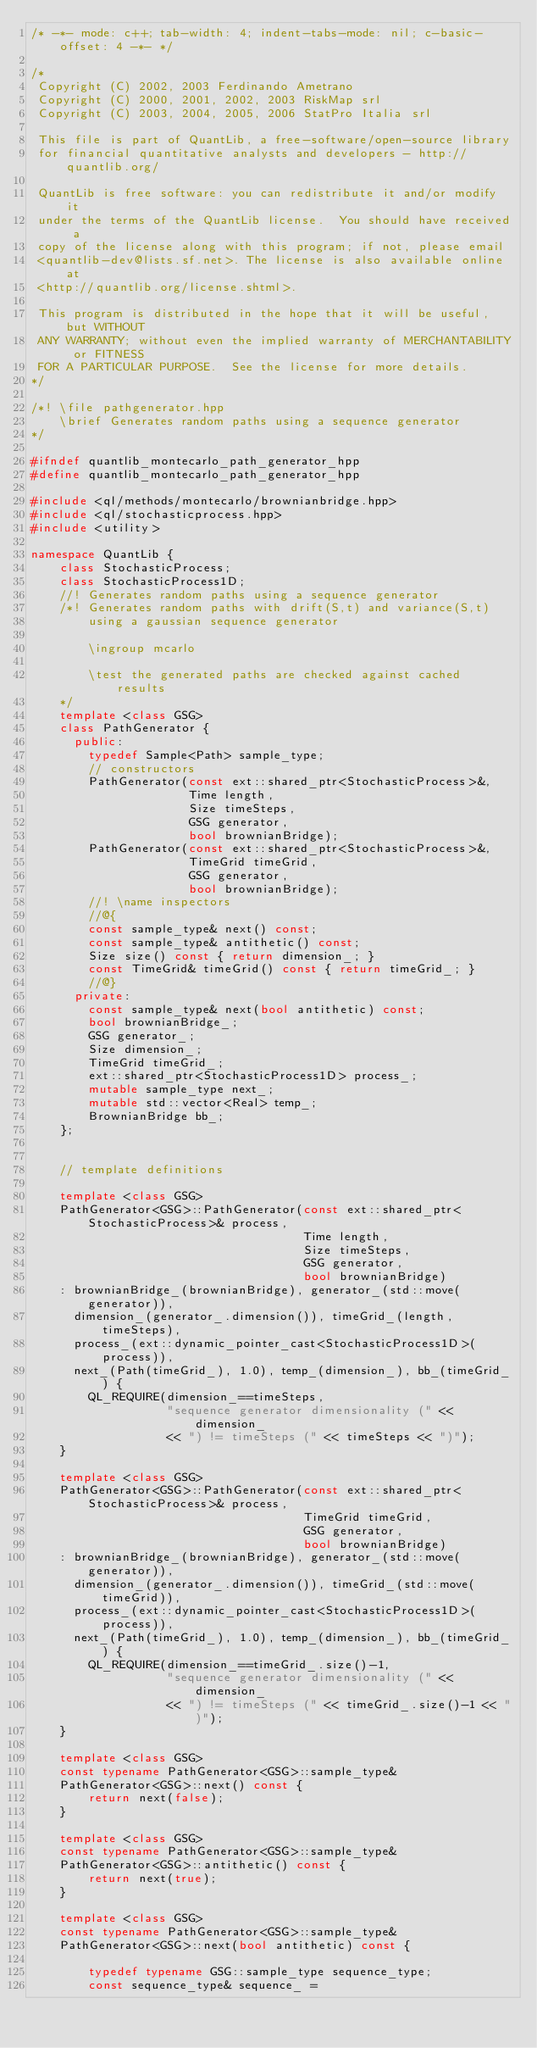Convert code to text. <code><loc_0><loc_0><loc_500><loc_500><_C++_>/* -*- mode: c++; tab-width: 4; indent-tabs-mode: nil; c-basic-offset: 4 -*- */

/*
 Copyright (C) 2002, 2003 Ferdinando Ametrano
 Copyright (C) 2000, 2001, 2002, 2003 RiskMap srl
 Copyright (C) 2003, 2004, 2005, 2006 StatPro Italia srl

 This file is part of QuantLib, a free-software/open-source library
 for financial quantitative analysts and developers - http://quantlib.org/

 QuantLib is free software: you can redistribute it and/or modify it
 under the terms of the QuantLib license.  You should have received a
 copy of the license along with this program; if not, please email
 <quantlib-dev@lists.sf.net>. The license is also available online at
 <http://quantlib.org/license.shtml>.

 This program is distributed in the hope that it will be useful, but WITHOUT
 ANY WARRANTY; without even the implied warranty of MERCHANTABILITY or FITNESS
 FOR A PARTICULAR PURPOSE.  See the license for more details.
*/

/*! \file pathgenerator.hpp
    \brief Generates random paths using a sequence generator
*/

#ifndef quantlib_montecarlo_path_generator_hpp
#define quantlib_montecarlo_path_generator_hpp

#include <ql/methods/montecarlo/brownianbridge.hpp>
#include <ql/stochasticprocess.hpp>
#include <utility>

namespace QuantLib {
    class StochasticProcess;
    class StochasticProcess1D;
    //! Generates random paths using a sequence generator
    /*! Generates random paths with drift(S,t) and variance(S,t)
        using a gaussian sequence generator

        \ingroup mcarlo

        \test the generated paths are checked against cached results
    */
    template <class GSG>
    class PathGenerator {
      public:
        typedef Sample<Path> sample_type;
        // constructors
        PathGenerator(const ext::shared_ptr<StochasticProcess>&,
                      Time length,
                      Size timeSteps,
                      GSG generator,
                      bool brownianBridge);
        PathGenerator(const ext::shared_ptr<StochasticProcess>&,
                      TimeGrid timeGrid,
                      GSG generator,
                      bool brownianBridge);
        //! \name inspectors
        //@{
        const sample_type& next() const;
        const sample_type& antithetic() const;
        Size size() const { return dimension_; }
        const TimeGrid& timeGrid() const { return timeGrid_; }
        //@}
      private:
        const sample_type& next(bool antithetic) const;
        bool brownianBridge_;
        GSG generator_;
        Size dimension_;
        TimeGrid timeGrid_;
        ext::shared_ptr<StochasticProcess1D> process_;
        mutable sample_type next_;
        mutable std::vector<Real> temp_;
        BrownianBridge bb_;
    };


    // template definitions

    template <class GSG>
    PathGenerator<GSG>::PathGenerator(const ext::shared_ptr<StochasticProcess>& process,
                                      Time length,
                                      Size timeSteps,
                                      GSG generator,
                                      bool brownianBridge)
    : brownianBridge_(brownianBridge), generator_(std::move(generator)),
      dimension_(generator_.dimension()), timeGrid_(length, timeSteps),
      process_(ext::dynamic_pointer_cast<StochasticProcess1D>(process)),
      next_(Path(timeGrid_), 1.0), temp_(dimension_), bb_(timeGrid_) {
        QL_REQUIRE(dimension_==timeSteps,
                   "sequence generator dimensionality (" << dimension_
                   << ") != timeSteps (" << timeSteps << ")");
    }

    template <class GSG>
    PathGenerator<GSG>::PathGenerator(const ext::shared_ptr<StochasticProcess>& process,
                                      TimeGrid timeGrid,
                                      GSG generator,
                                      bool brownianBridge)
    : brownianBridge_(brownianBridge), generator_(std::move(generator)),
      dimension_(generator_.dimension()), timeGrid_(std::move(timeGrid)),
      process_(ext::dynamic_pointer_cast<StochasticProcess1D>(process)),
      next_(Path(timeGrid_), 1.0), temp_(dimension_), bb_(timeGrid_) {
        QL_REQUIRE(dimension_==timeGrid_.size()-1,
                   "sequence generator dimensionality (" << dimension_
                   << ") != timeSteps (" << timeGrid_.size()-1 << ")");
    }

    template <class GSG>
    const typename PathGenerator<GSG>::sample_type&
    PathGenerator<GSG>::next() const {
        return next(false);
    }

    template <class GSG>
    const typename PathGenerator<GSG>::sample_type&
    PathGenerator<GSG>::antithetic() const {
        return next(true);
    }

    template <class GSG>
    const typename PathGenerator<GSG>::sample_type&
    PathGenerator<GSG>::next(bool antithetic) const {

        typedef typename GSG::sample_type sequence_type;
        const sequence_type& sequence_ =</code> 